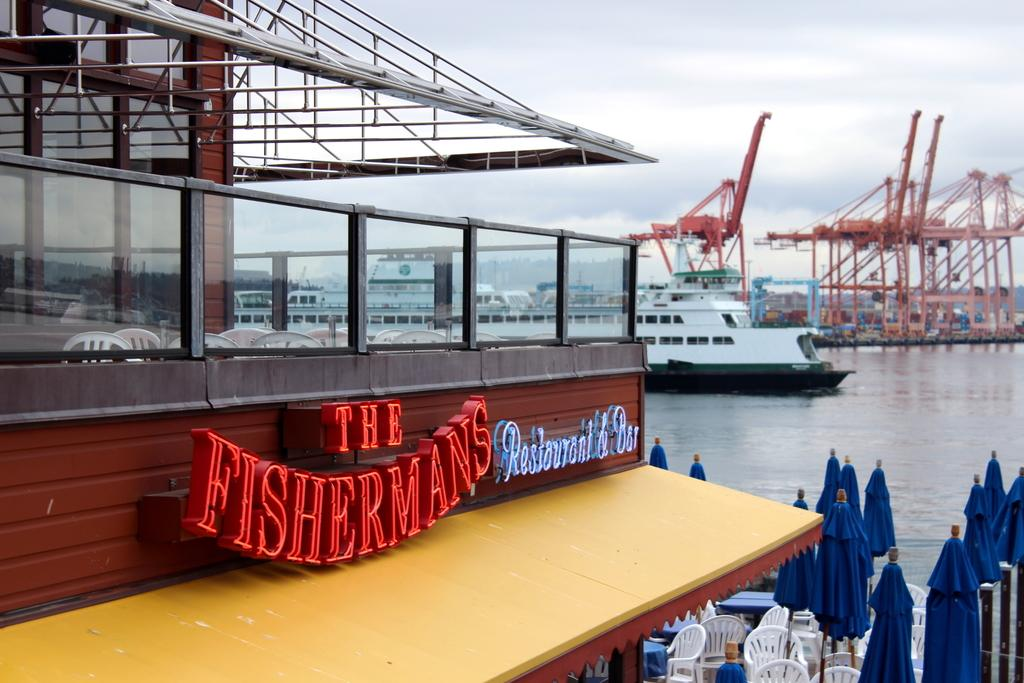What type of establishment is shown in the image? There is a restaurant in the image. What is located below the restaurant? There are chairs below the restaurant. What can be seen in the background of the image? There is a sea visible in the background. What is present in the sea? There is a ship and cranes in the sea. Where is the throne located in the image? There is no throne present in the image. How many windows can be seen in the restaurant? The provided facts do not mention any windows in the restaurant, so we cannot determine the number of windows. 